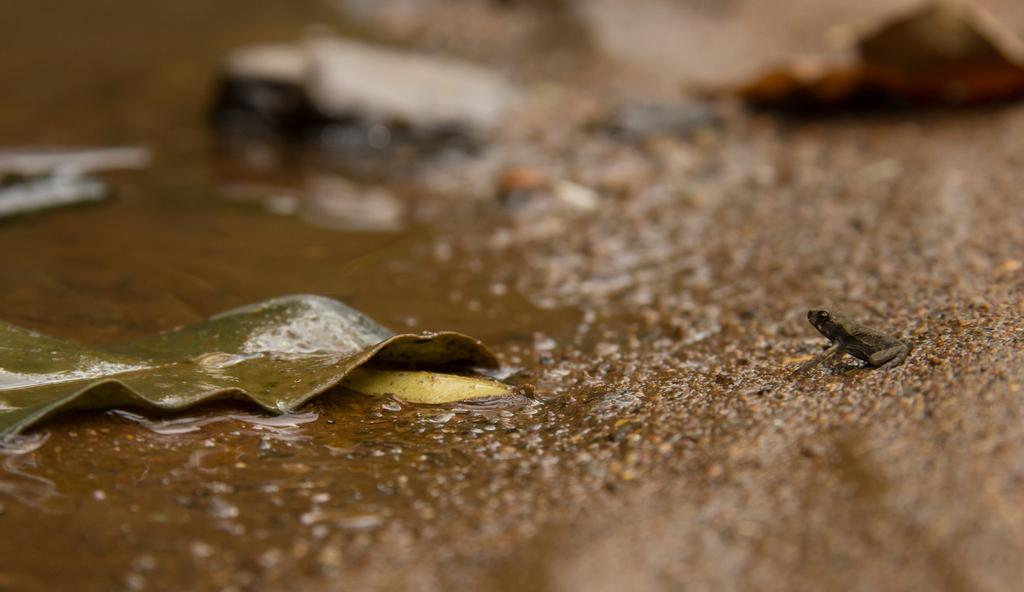What is present at the bottom of the image? There is water, a leaf, and a frog at the bottom of the image. Can you describe the water in the image? The water is at the bottom of the image. What else is present along with the water? There is a leaf and a frog at the bottom of the image. What type of paste is being used by the frog in the image? There is no paste present in the image, and the frog is not shown using any paste. 